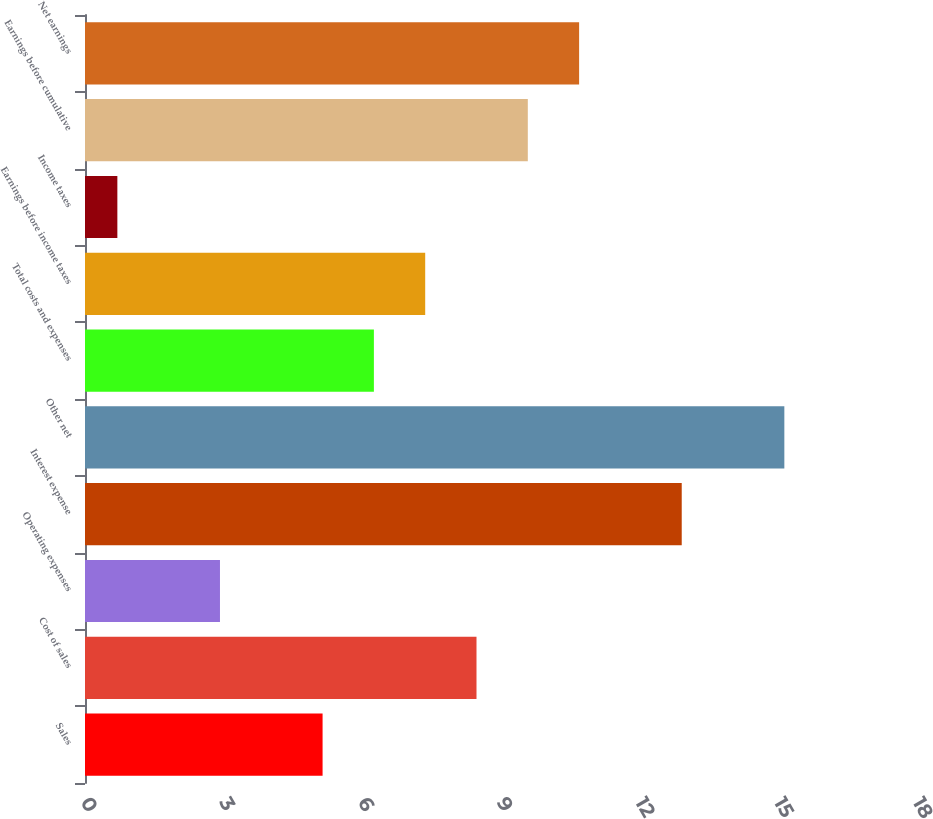Convert chart to OTSL. <chart><loc_0><loc_0><loc_500><loc_500><bar_chart><fcel>Sales<fcel>Cost of sales<fcel>Operating expenses<fcel>Interest expense<fcel>Other net<fcel>Total costs and expenses<fcel>Earnings before income taxes<fcel>Income taxes<fcel>Earnings before cumulative<fcel>Net earnings<nl><fcel>5.14<fcel>8.47<fcel>2.92<fcel>12.91<fcel>15.13<fcel>6.25<fcel>7.36<fcel>0.7<fcel>9.58<fcel>10.69<nl></chart> 